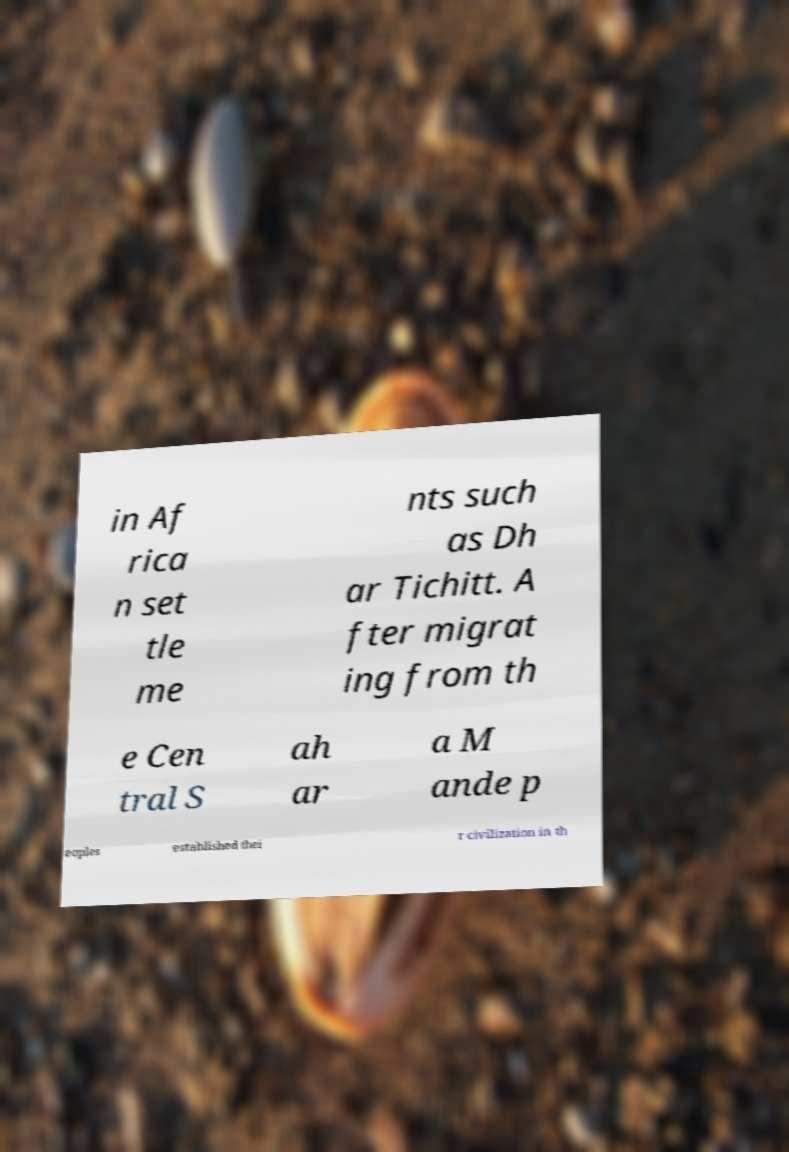There's text embedded in this image that I need extracted. Can you transcribe it verbatim? in Af rica n set tle me nts such as Dh ar Tichitt. A fter migrat ing from th e Cen tral S ah ar a M ande p eoples established thei r civilization in th 